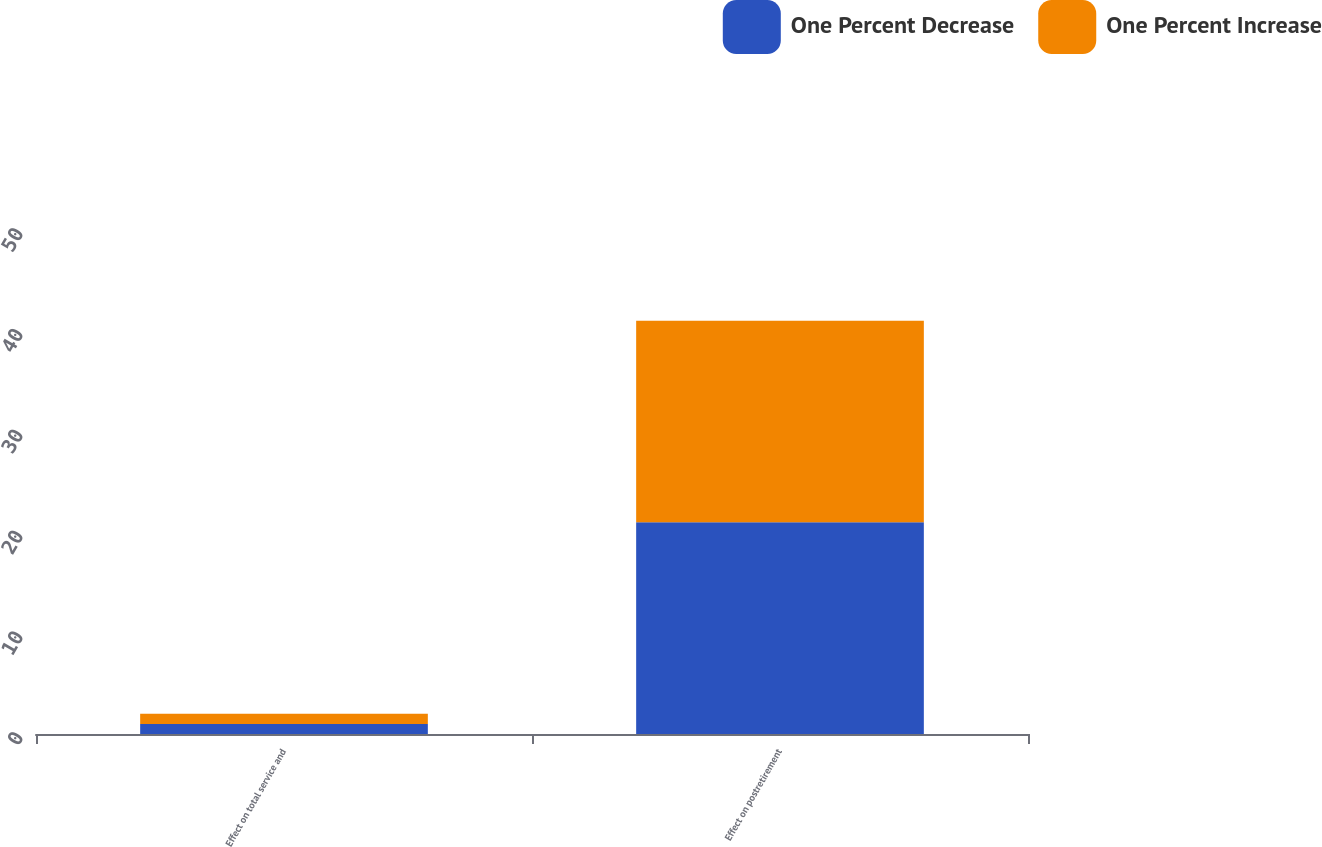Convert chart. <chart><loc_0><loc_0><loc_500><loc_500><stacked_bar_chart><ecel><fcel>Effect on total service and<fcel>Effect on postretirement<nl><fcel>One Percent Decrease<fcel>1<fcel>21<nl><fcel>One Percent Increase<fcel>1<fcel>20<nl></chart> 